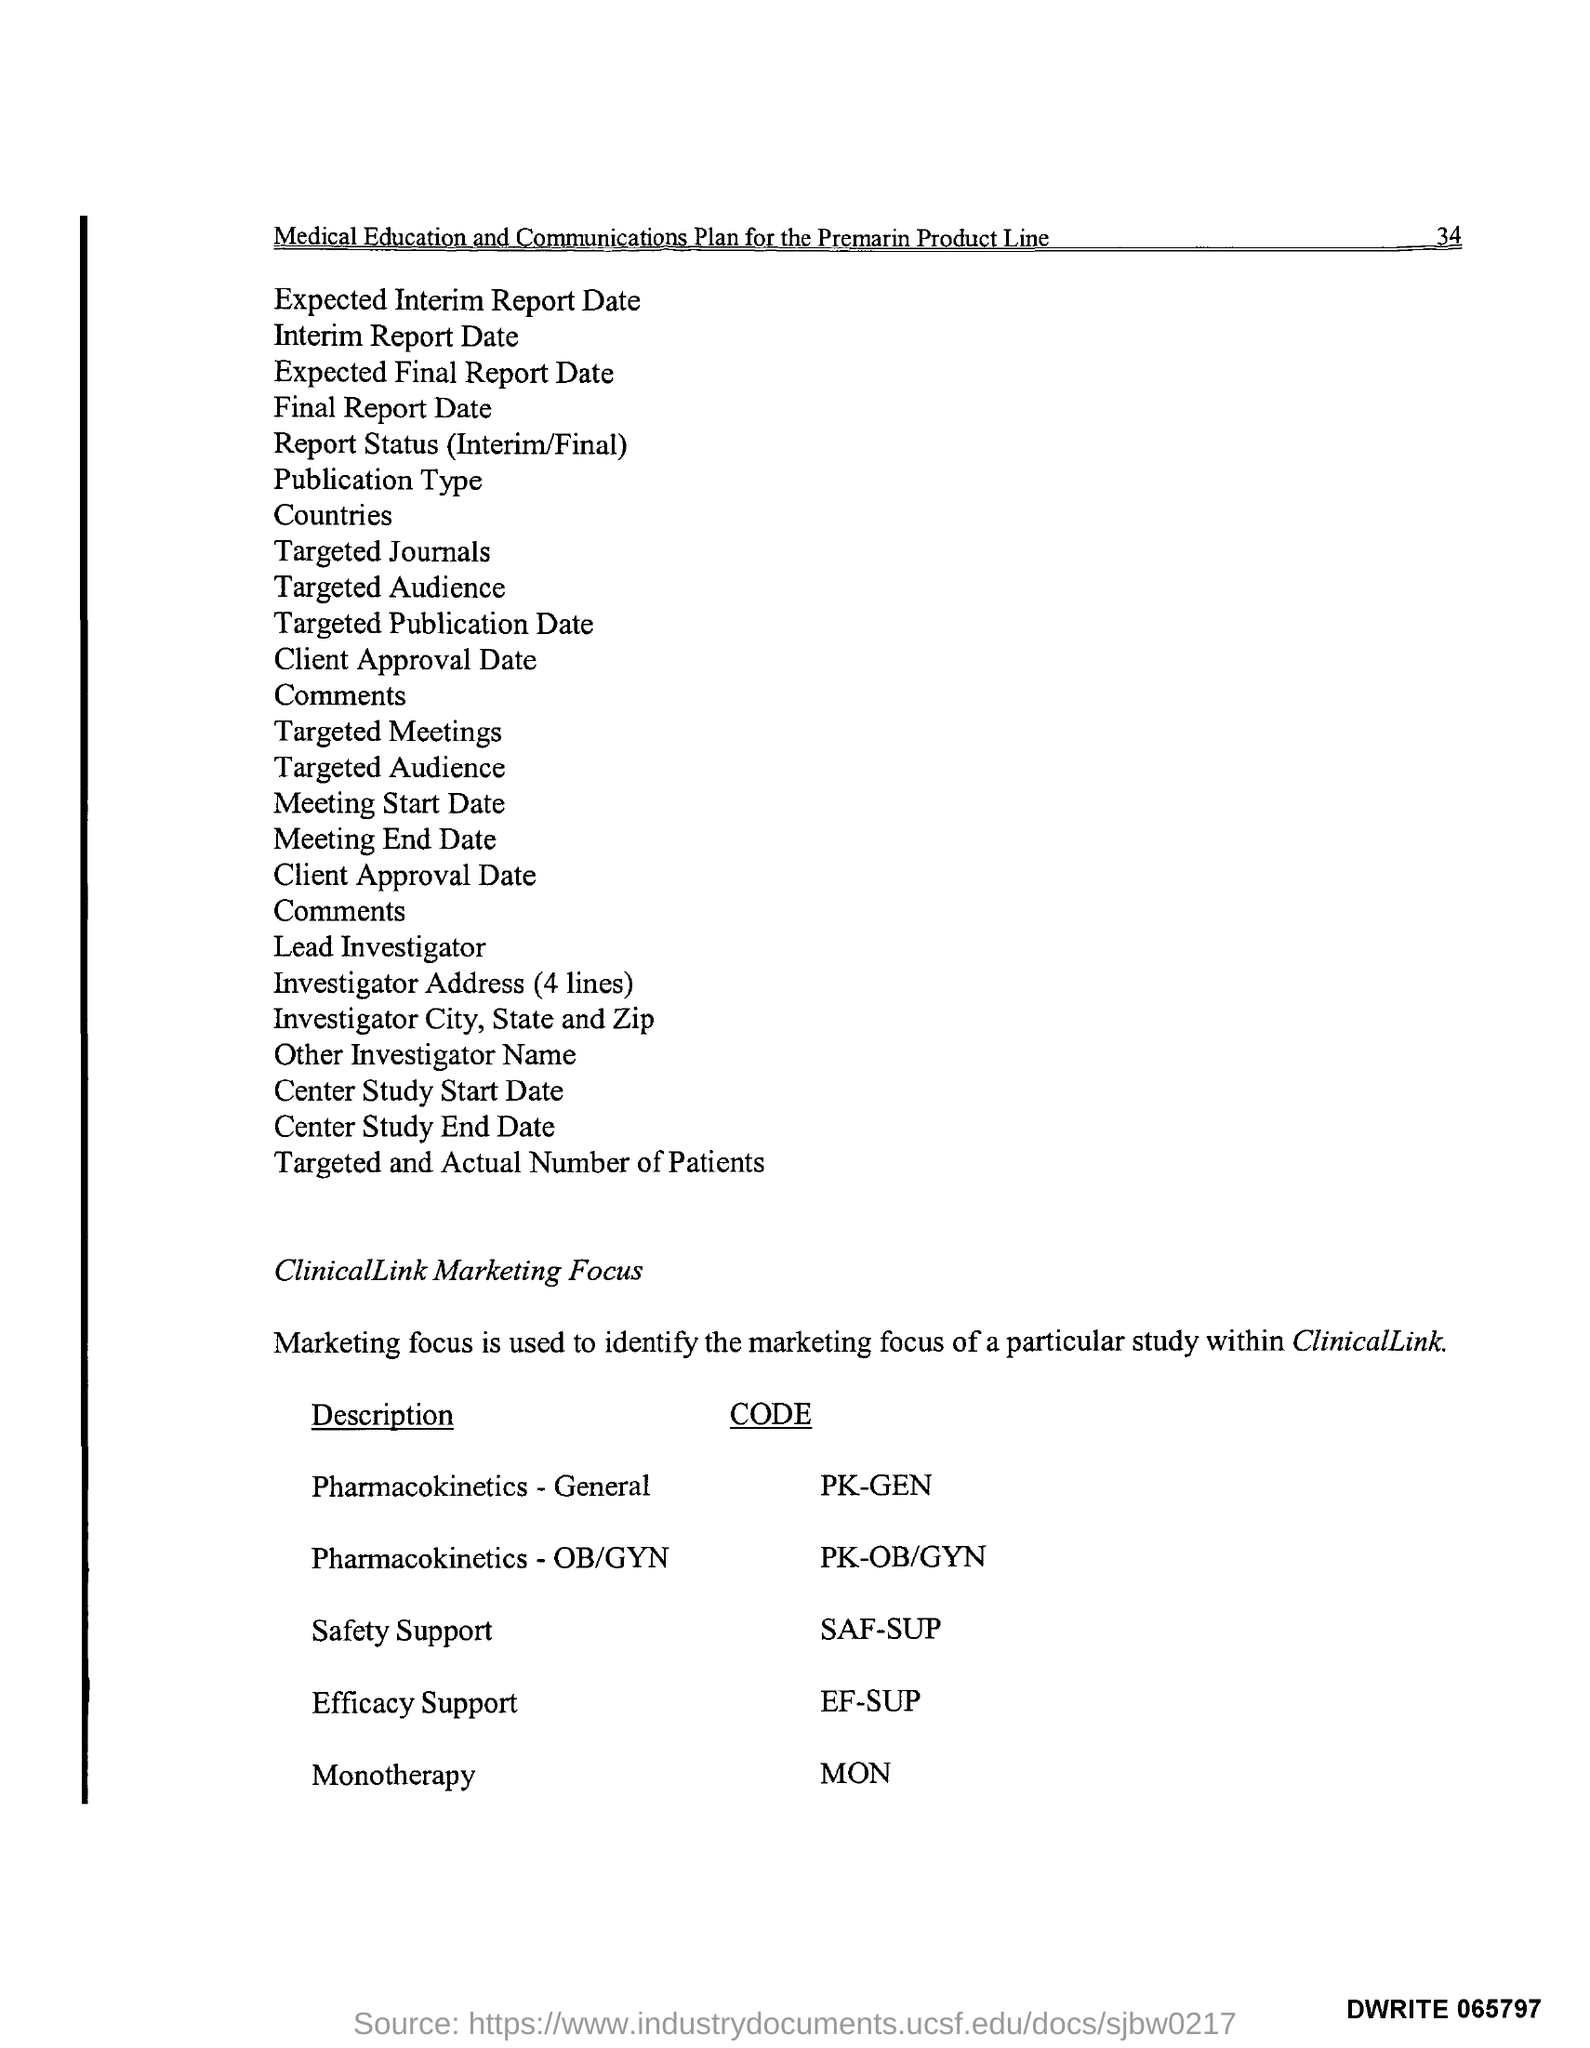Outline some significant characteristics in this image. There are four lines in the investigator's address. 